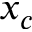<formula> <loc_0><loc_0><loc_500><loc_500>x _ { c }</formula> 